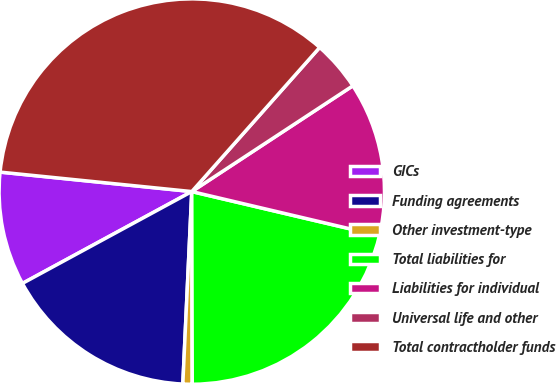Convert chart to OTSL. <chart><loc_0><loc_0><loc_500><loc_500><pie_chart><fcel>GICs<fcel>Funding agreements<fcel>Other investment-type<fcel>Total liabilities for<fcel>Liabilities for individual<fcel>Universal life and other<fcel>Total contractholder funds<nl><fcel>9.52%<fcel>16.35%<fcel>0.78%<fcel>21.28%<fcel>12.93%<fcel>4.2%<fcel>34.94%<nl></chart> 